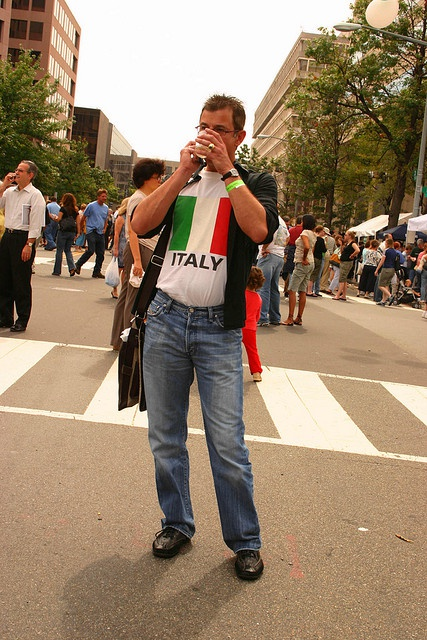Describe the objects in this image and their specific colors. I can see people in gray, black, brown, and tan tones, people in gray, black, and maroon tones, people in gray, black, tan, and brown tones, people in gray, black, maroon, and tan tones, and handbag in gray, black, and maroon tones in this image. 